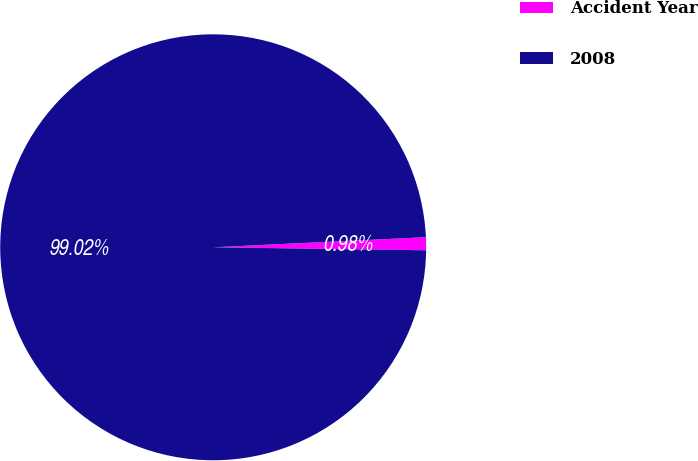<chart> <loc_0><loc_0><loc_500><loc_500><pie_chart><fcel>Accident Year<fcel>2008<nl><fcel>0.98%<fcel>99.02%<nl></chart> 